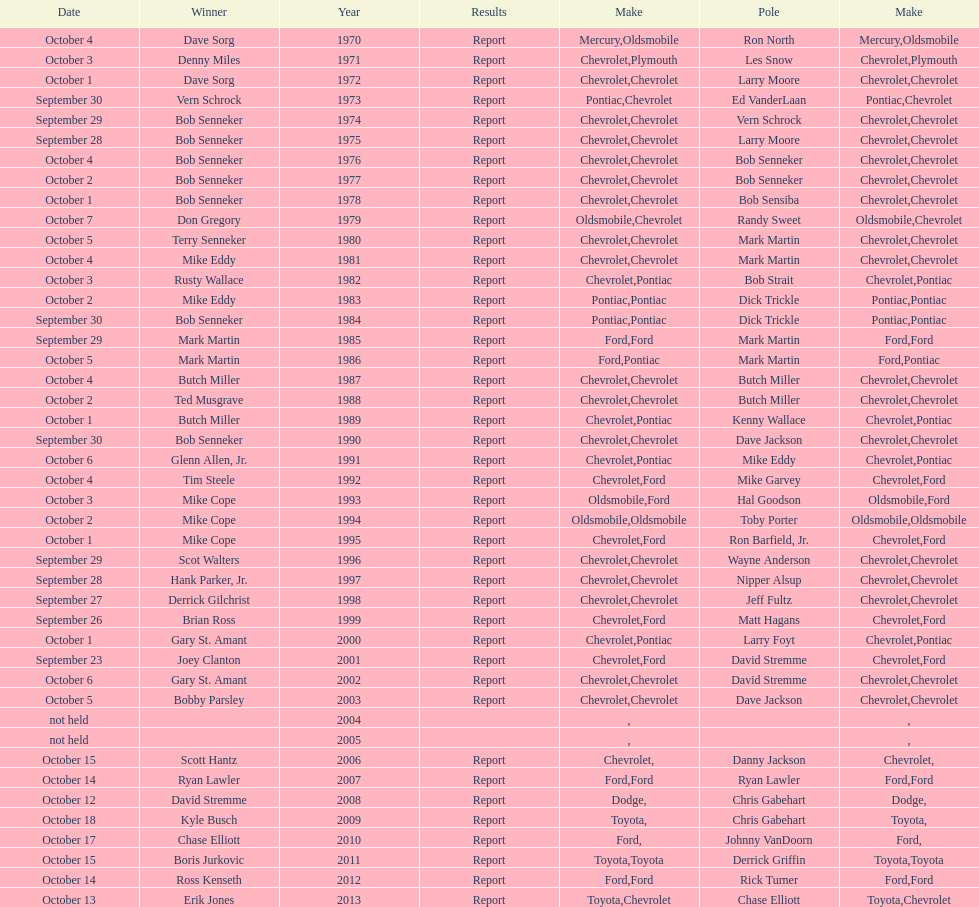Who on the list has the highest number of consecutive wins? Bob Senneker. 